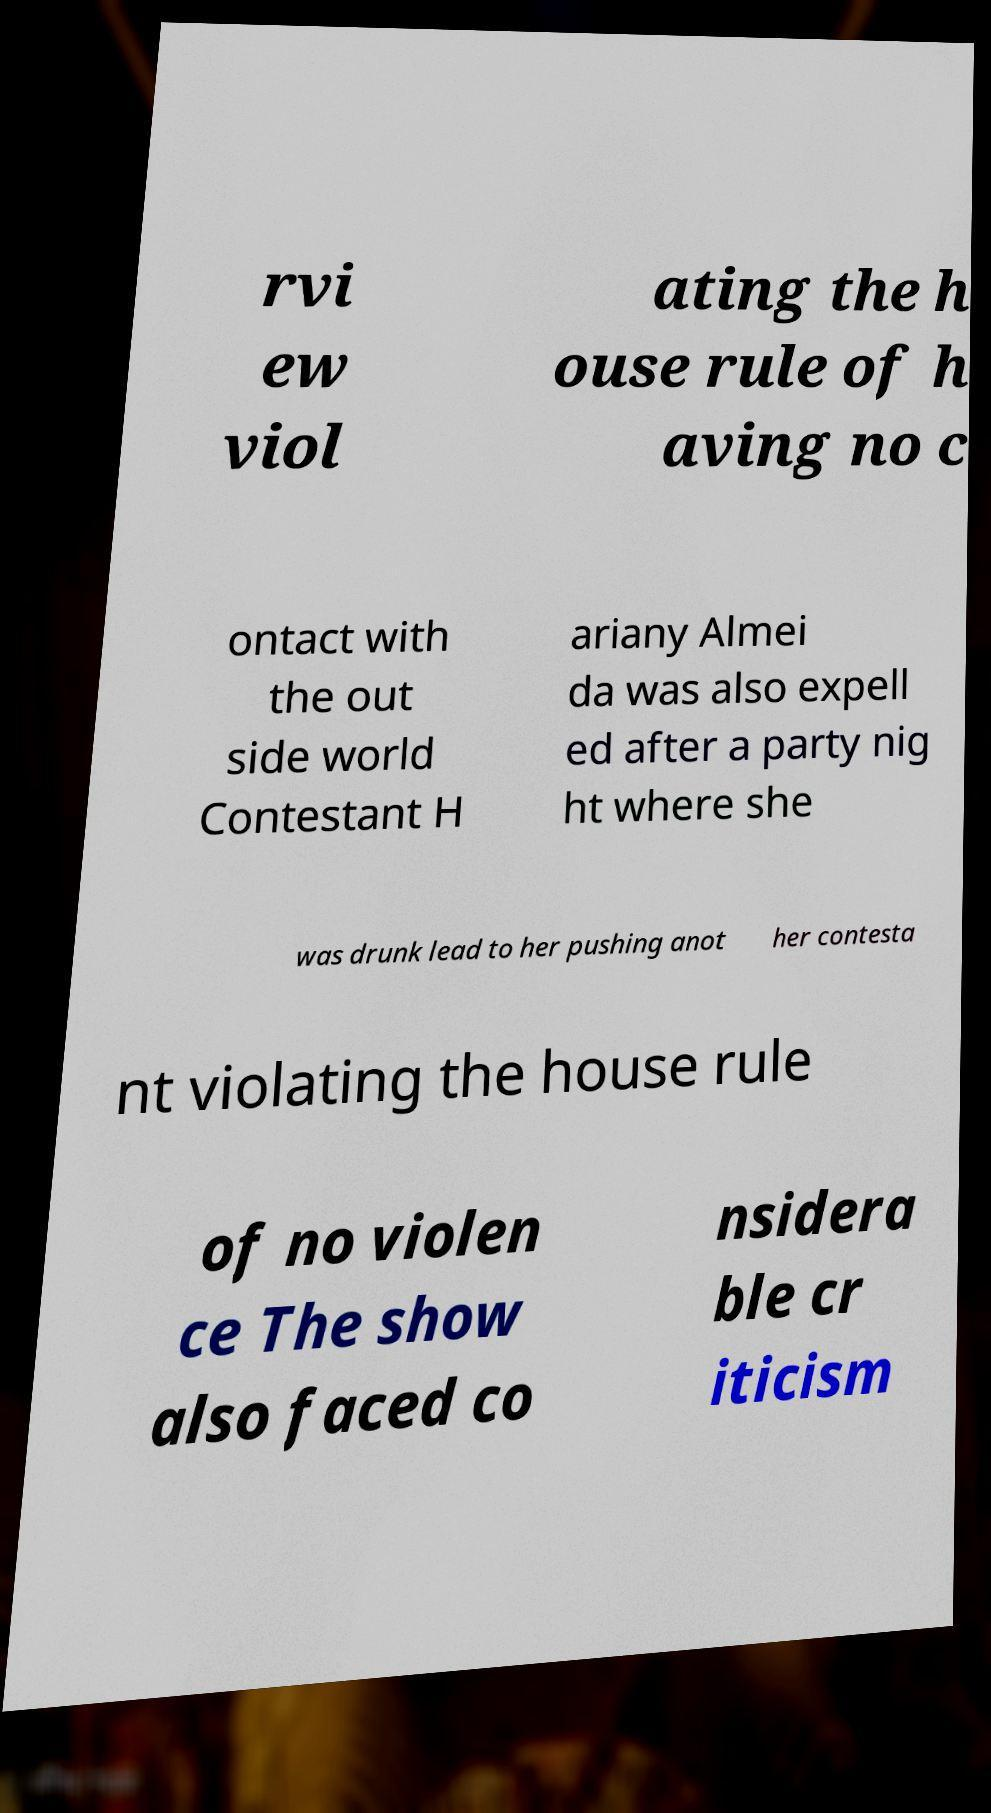Please identify and transcribe the text found in this image. rvi ew viol ating the h ouse rule of h aving no c ontact with the out side world Contestant H ariany Almei da was also expell ed after a party nig ht where she was drunk lead to her pushing anot her contesta nt violating the house rule of no violen ce The show also faced co nsidera ble cr iticism 